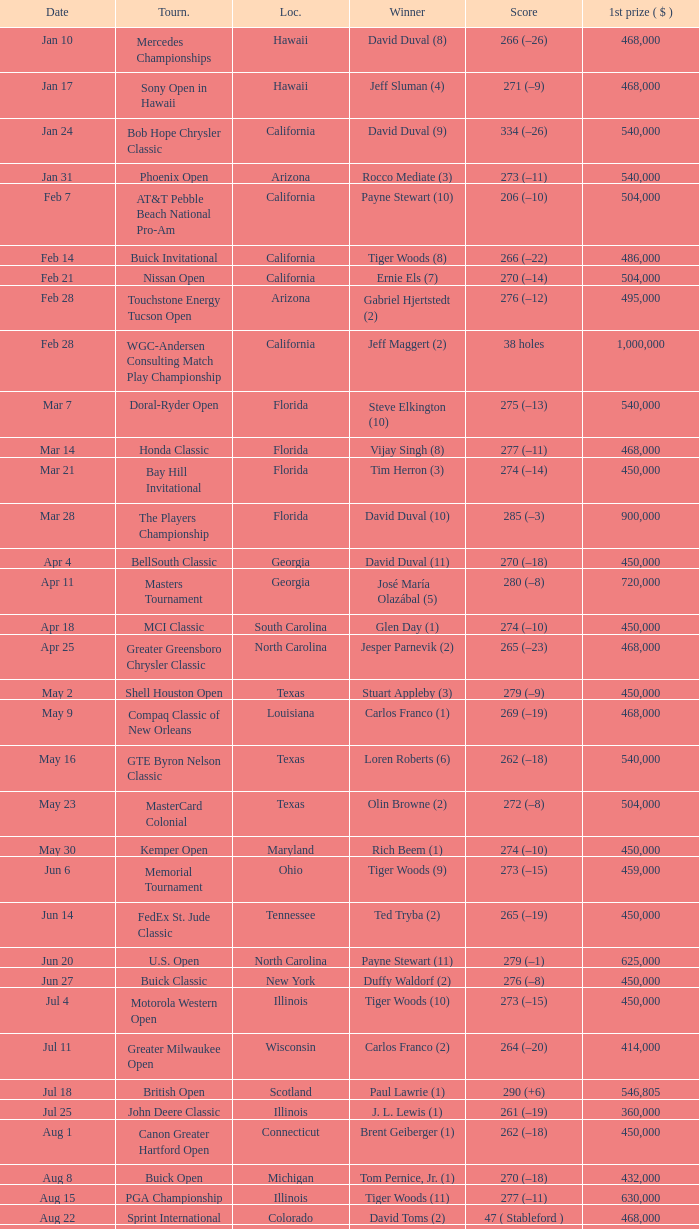What is the date of the Greater Greensboro Chrysler Classic? Apr 25. 